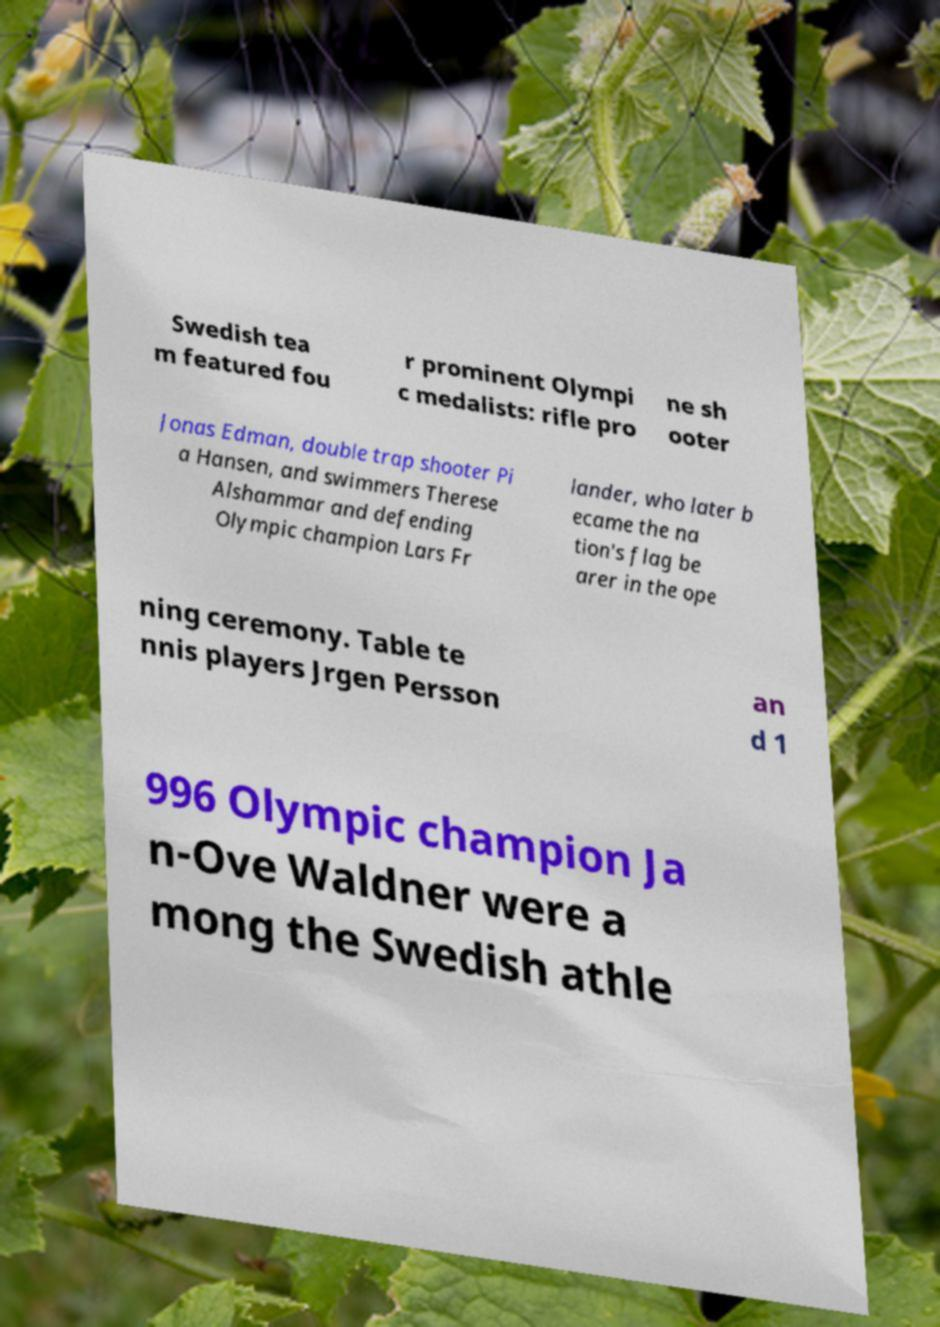Can you read and provide the text displayed in the image?This photo seems to have some interesting text. Can you extract and type it out for me? Swedish tea m featured fou r prominent Olympi c medalists: rifle pro ne sh ooter Jonas Edman, double trap shooter Pi a Hansen, and swimmers Therese Alshammar and defending Olympic champion Lars Fr lander, who later b ecame the na tion's flag be arer in the ope ning ceremony. Table te nnis players Jrgen Persson an d 1 996 Olympic champion Ja n-Ove Waldner were a mong the Swedish athle 